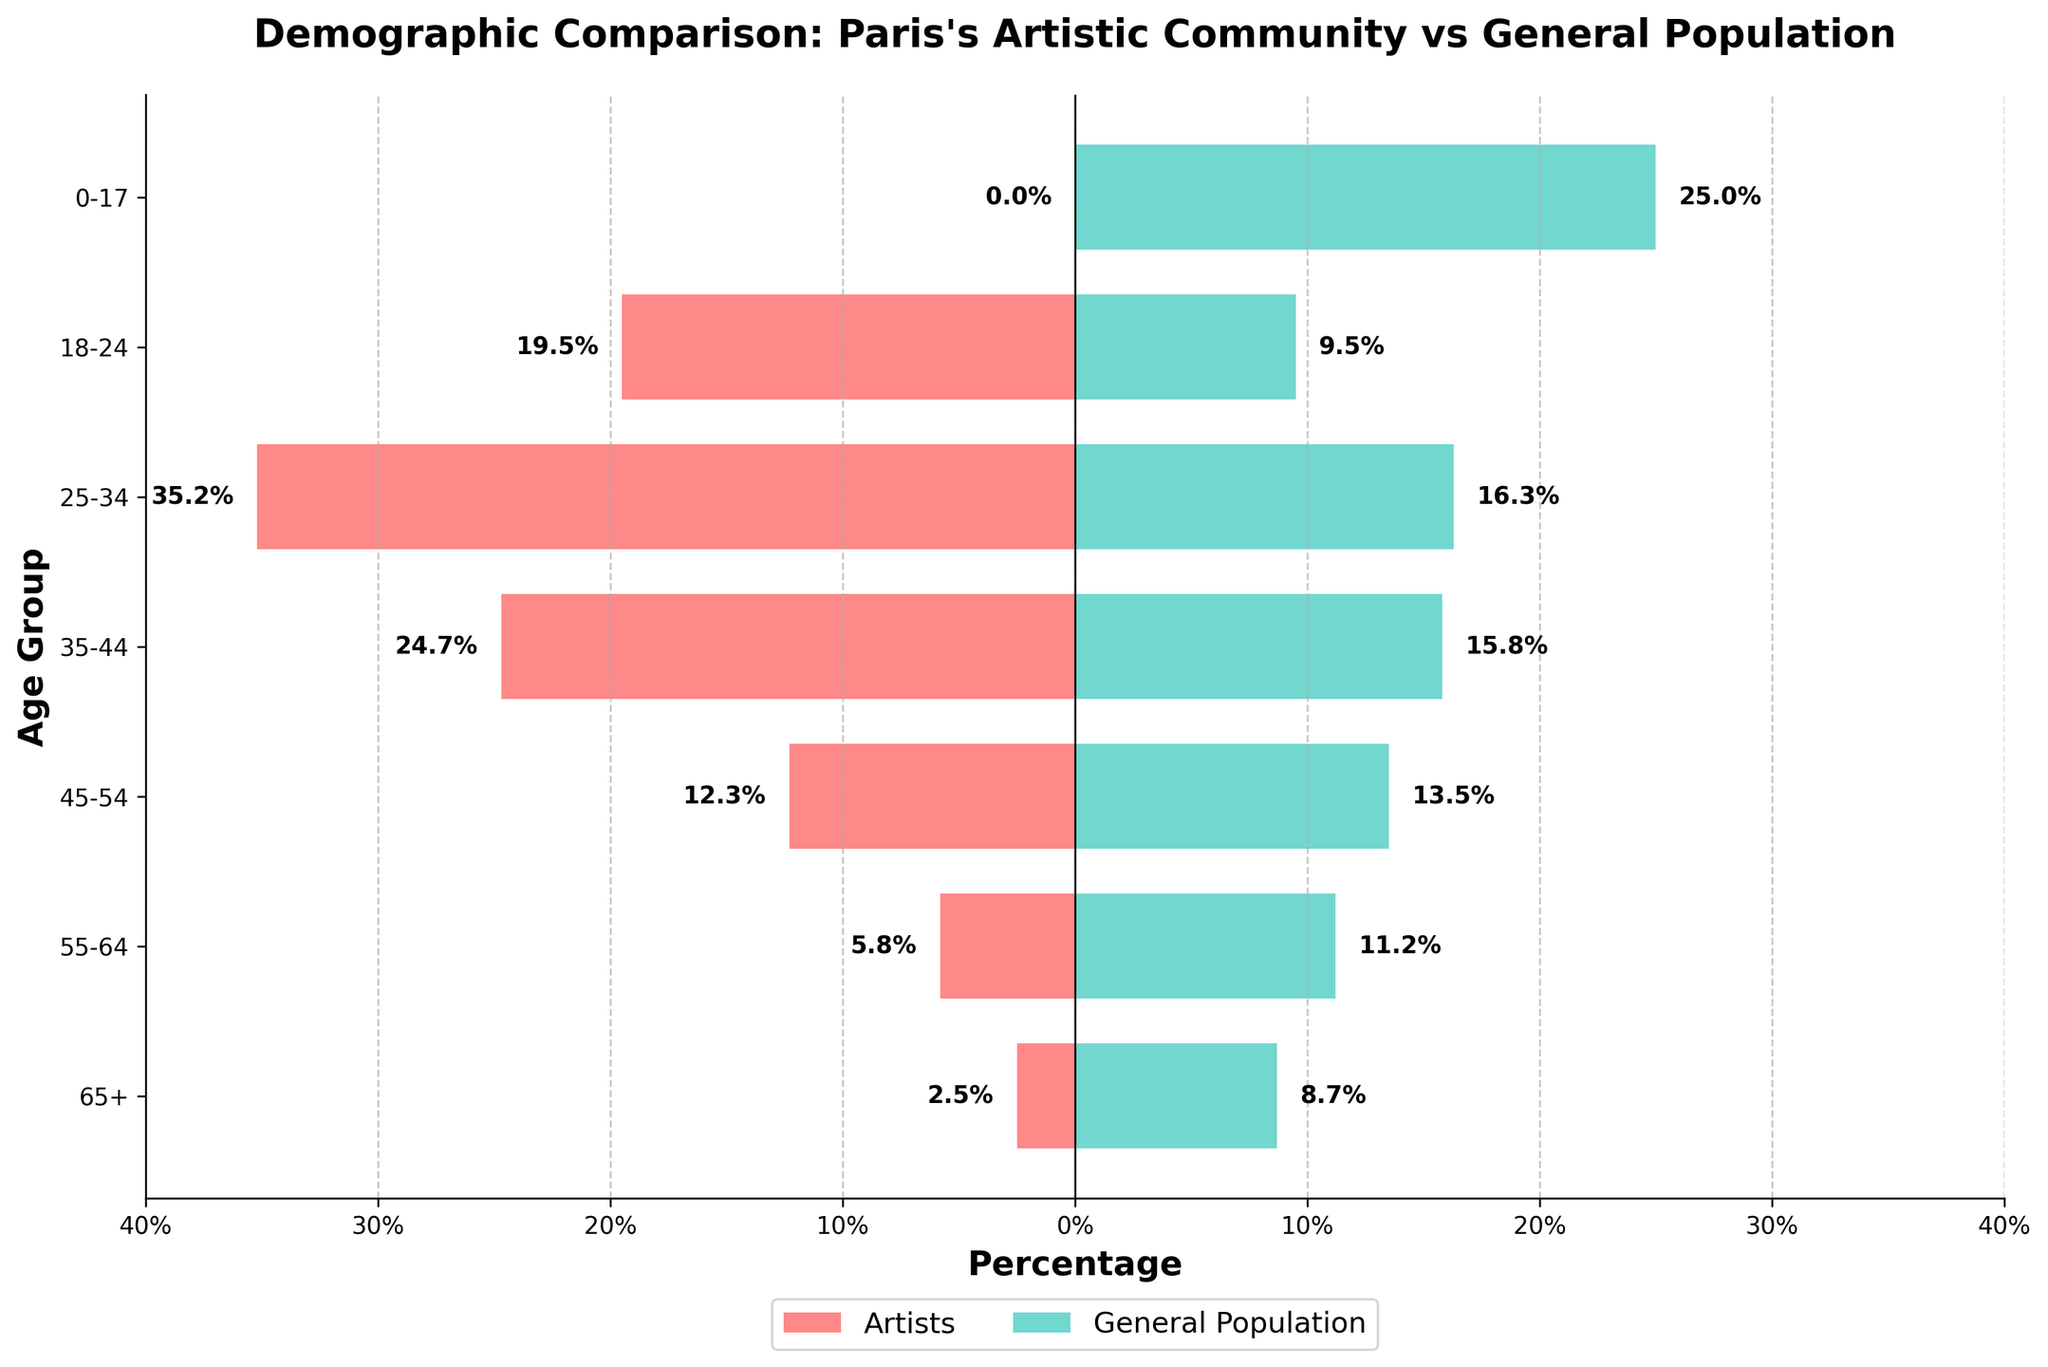Which age group has the highest percentage among artists? The highest percentage among artists is found by identifying the maximum value in the 'Artists' column of the figure. The highest percentage is 35.2% for the age group 25-34.
Answer: 25-34 Which age group has the highest percentage in the general population? The highest percentage in the general population is found by identifying the maximum value in the 'General Population' column of the figure. The highest percentage is 25% for the age group 0-17.
Answer: 0-17 What is the percentage difference between artists and the general population in the 25-34 age group? To find the percentage difference, subtract the percentage of the general population in the 25-34 age group from the percentage of artists in the same age group (35.2% - 16.3%).
Answer: 18.9% In which age group do artists have the smallest percentage? The smallest percentage among artists can be identified by finding the minimum value in the 'Artists' column. This value is 0% for the age group 0-17.
Answer: 0-17 How do the percentages of artists and the general population compare in the 65+ age group? Check the values for the 65+ age group: Artists have 2.5% and the general population has 8.7%. The general population percentage is higher.
Answer: General population higher What is the combined percentage of artists in the 18-24 and 25-34 age groups? Sum the percentages for artists in the 18-24 (19.5%) and 25-34 (35.2%) age groups (19.5% + 35.2%).
Answer: 54.7% What is the trend of artists' percentages as age increases from 18-24 to 65+? Observing the 'Artists' percentages from 18-24 to 65+: 19.5%, 35.2%, 24.7%, 12.3%, 5.8%, 2.5%, they generally decrease.
Answer: Decreasing Which age group has a higher percentage of artists compared to the general population in every instance? Check each age group where the percentage of artists is higher than the general population: 
18-24: Artists 19.5% > General 9.5%, 
25-34: Artists 35.2% > General 16.3%, 
35-44: Artists 24.7 > General 15.8%. These three age groups all have higher percentages of artists.
Answer: 18-24, 25-34, 35-44 